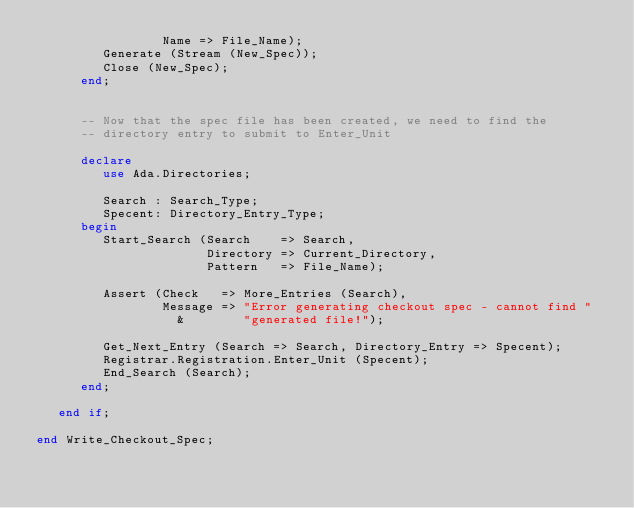<code> <loc_0><loc_0><loc_500><loc_500><_Ada_>                 Name => File_Name);
         Generate (Stream (New_Spec));
         Close (New_Spec);
      end;

      
      -- Now that the spec file has been created, we need to find the
      -- directory entry to submit to Enter_Unit
      
      declare
         use Ada.Directories;
         
         Search : Search_Type;
         Specent: Directory_Entry_Type;
      begin
         Start_Search (Search    => Search,
                       Directory => Current_Directory,
                       Pattern   => File_Name);
         
         Assert (Check   => More_Entries (Search),
                 Message => "Error generating checkout spec - cannot find "
                   &        "generated file!");
         
         Get_Next_Entry (Search => Search, Directory_Entry => Specent);
         Registrar.Registration.Enter_Unit (Specent);
         End_Search (Search);
      end;
      
   end if;
   
end Write_Checkout_Spec;
</code> 